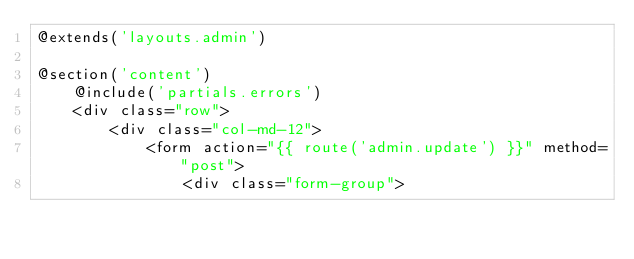<code> <loc_0><loc_0><loc_500><loc_500><_PHP_>@extends('layouts.admin')

@section('content')
    @include('partials.errors')
    <div class="row">
        <div class="col-md-12">
            <form action="{{ route('admin.update') }}" method="post">
                <div class="form-group"></code> 